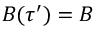Convert formula to latex. <formula><loc_0><loc_0><loc_500><loc_500>B ( \tau ^ { \prime } ) = B</formula> 